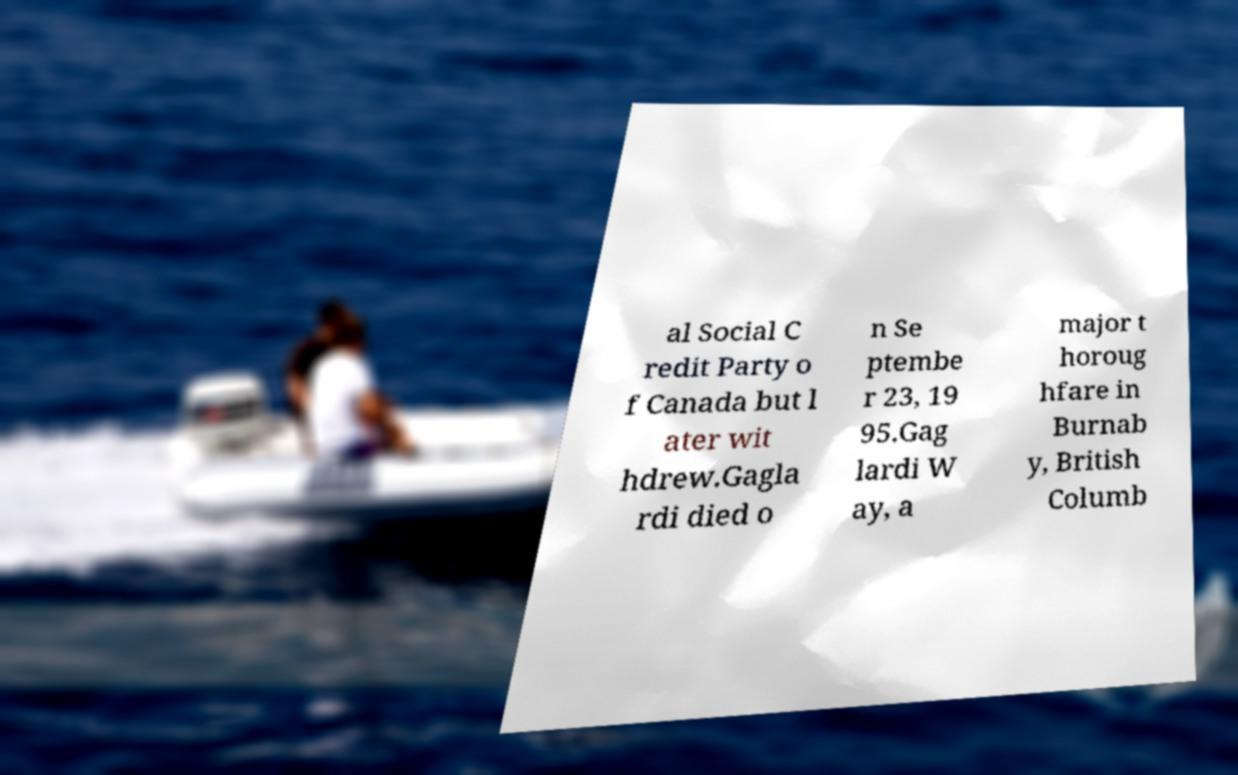There's text embedded in this image that I need extracted. Can you transcribe it verbatim? al Social C redit Party o f Canada but l ater wit hdrew.Gagla rdi died o n Se ptembe r 23, 19 95.Gag lardi W ay, a major t horoug hfare in Burnab y, British Columb 